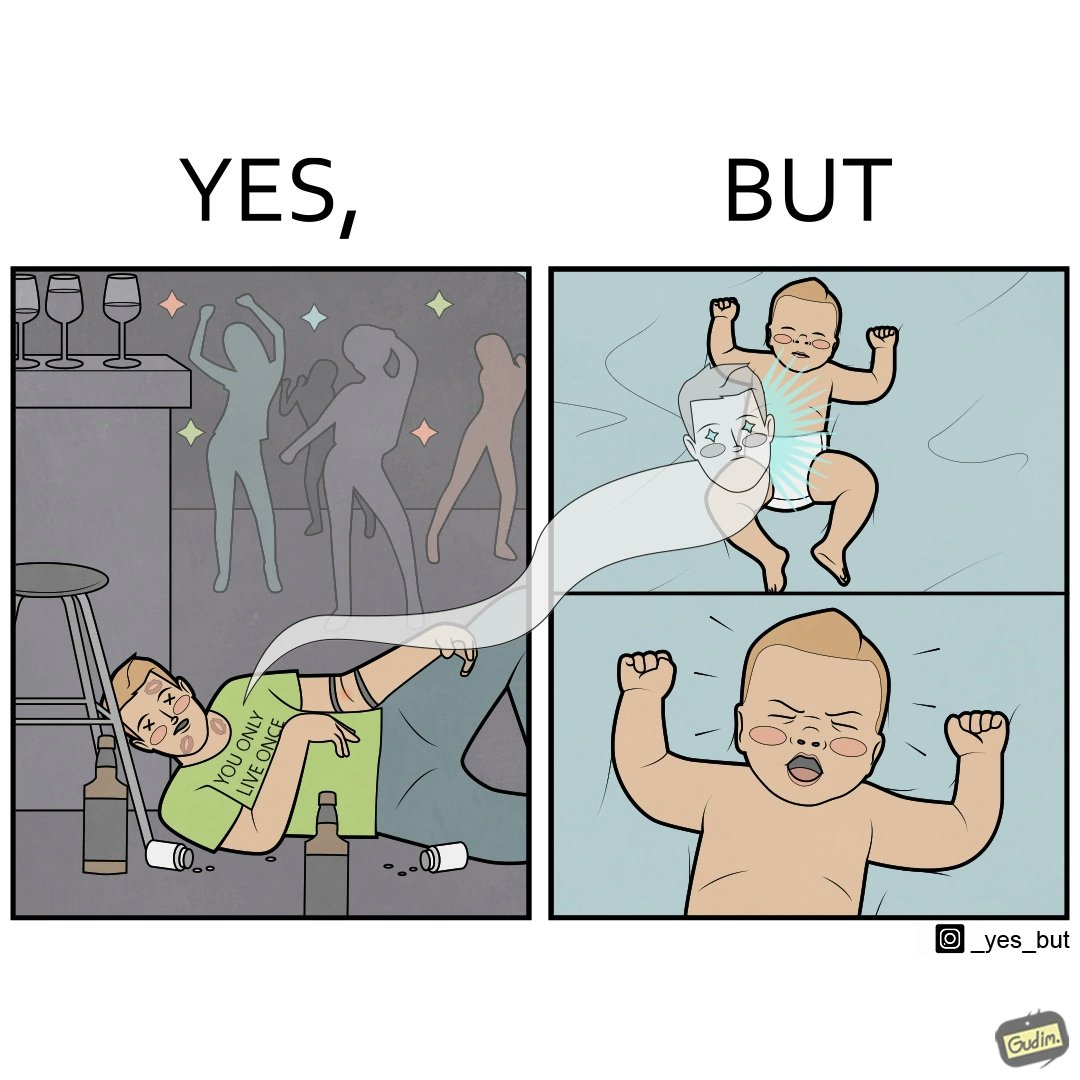Explain the humor or irony in this image. The image is ironical, as the person is believes that "You Only Live Once" (as can be seen from the t-shirt), and hence drinks and parties a lot, and is dead probably due to drug overdose. However, it is shown that the person re-incarnates as a crying baby, which goes against the person's belief. 